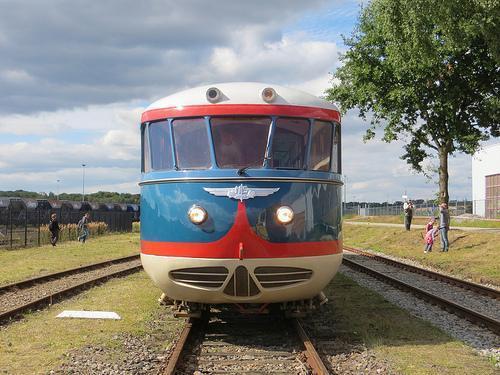How many trains are there?
Give a very brief answer. 1. 